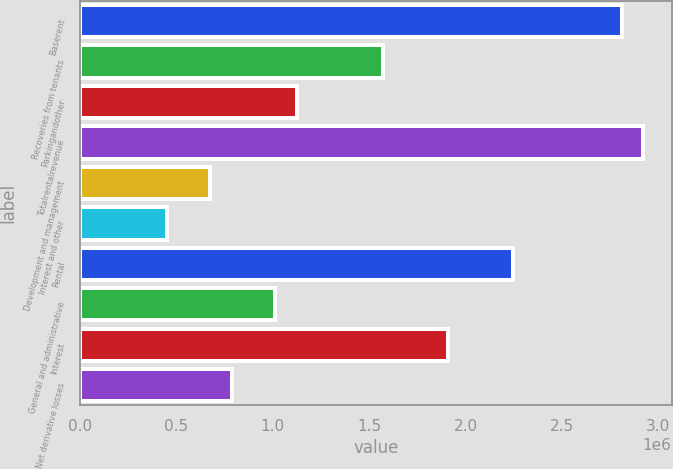Convert chart. <chart><loc_0><loc_0><loc_500><loc_500><bar_chart><fcel>Baserent<fcel>Recoveries from tenants<fcel>Parkingandother<fcel>Totalrentalrevenue<fcel>Development and management<fcel>Interest and other<fcel>Rental<fcel>General and administrative<fcel>Interest<fcel>Net derivative losses<nl><fcel>2.80969e+06<fcel>1.57343e+06<fcel>1.12388e+06<fcel>2.92208e+06<fcel>674326<fcel>449551<fcel>2.24775e+06<fcel>1.01149e+06<fcel>1.91059e+06<fcel>786714<nl></chart> 